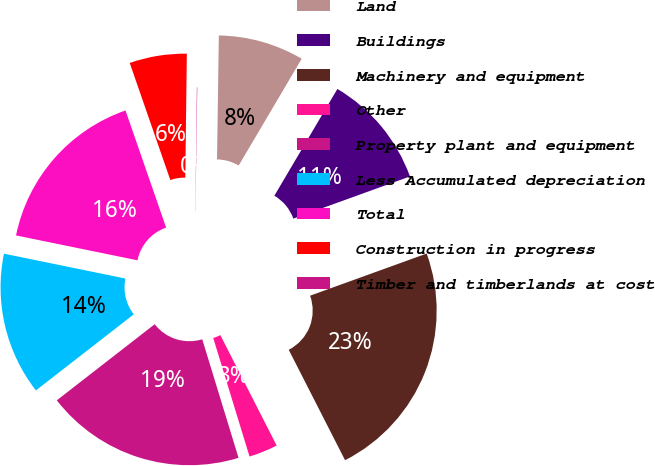<chart> <loc_0><loc_0><loc_500><loc_500><pie_chart><fcel>Land<fcel>Buildings<fcel>Machinery and equipment<fcel>Other<fcel>Property plant and equipment<fcel>Less Accumulated depreciation<fcel>Total<fcel>Construction in progress<fcel>Timber and timberlands at cost<nl><fcel>8.25%<fcel>10.99%<fcel>23.01%<fcel>2.78%<fcel>19.21%<fcel>13.73%<fcel>16.47%<fcel>5.51%<fcel>0.04%<nl></chart> 